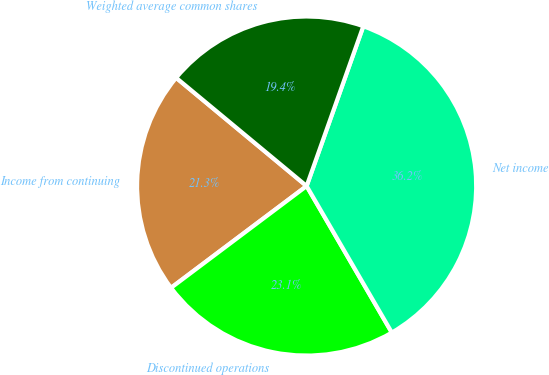Convert chart. <chart><loc_0><loc_0><loc_500><loc_500><pie_chart><fcel>Income from continuing<fcel>Discontinued operations<fcel>Net income<fcel>Weighted average common shares<nl><fcel>21.27%<fcel>23.13%<fcel>36.19%<fcel>19.4%<nl></chart> 